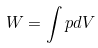<formula> <loc_0><loc_0><loc_500><loc_500>W = \int p d V</formula> 